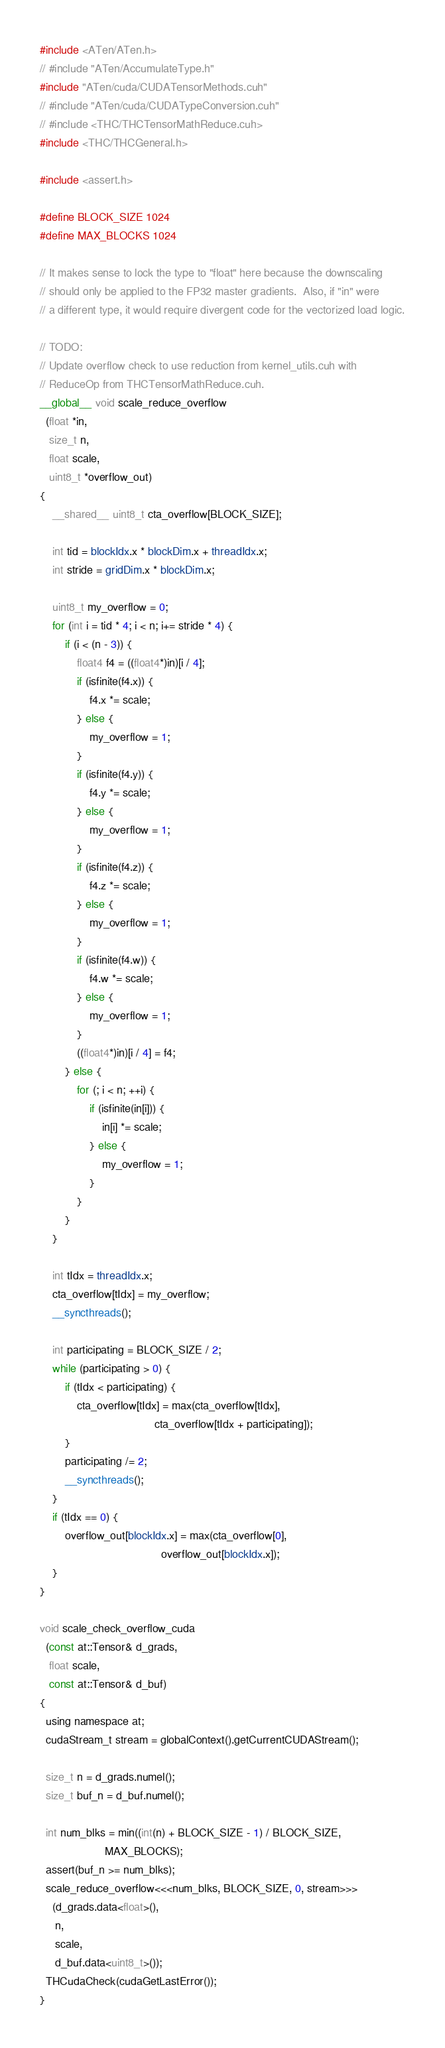Convert code to text. <code><loc_0><loc_0><loc_500><loc_500><_Cuda_>#include <ATen/ATen.h>
// #include "ATen/AccumulateType.h"
#include "ATen/cuda/CUDATensorMethods.cuh"
// #include "ATen/cuda/CUDATypeConversion.cuh"
// #include <THC/THCTensorMathReduce.cuh>
#include <THC/THCGeneral.h>

#include <assert.h>

#define BLOCK_SIZE 1024
#define MAX_BLOCKS 1024

// It makes sense to lock the type to "float" here because the downscaling
// should only be applied to the FP32 master gradients.  Also, if "in" were 
// a different type, it would require divergent code for the vectorized load logic.

// TODO:  
// Update overflow check to use reduction from kernel_utils.cuh with 
// ReduceOp from THCTensorMathReduce.cuh.
__global__ void scale_reduce_overflow
  (float *in, 
   size_t n, 
   float scale,
   uint8_t *overflow_out) 
{
    __shared__ uint8_t cta_overflow[BLOCK_SIZE];

    int tid = blockIdx.x * blockDim.x + threadIdx.x;
    int stride = gridDim.x * blockDim.x;

    uint8_t my_overflow = 0;
    for (int i = tid * 4; i < n; i+= stride * 4) {
        if (i < (n - 3)) {
            float4 f4 = ((float4*)in)[i / 4];
            if (isfinite(f4.x)) {
                f4.x *= scale;
            } else {
                my_overflow = 1;
            }
            if (isfinite(f4.y)) {
                f4.y *= scale;
            } else {
                my_overflow = 1;
            }
            if (isfinite(f4.z)) {
                f4.z *= scale;
            } else {
                my_overflow = 1;
            }
            if (isfinite(f4.w)) {
                f4.w *= scale;
            } else {
                my_overflow = 1;
            }
            ((float4*)in)[i / 4] = f4;
        } else {
            for (; i < n; ++i) {
                if (isfinite(in[i])) {
                    in[i] *= scale;
                } else {
                    my_overflow = 1;
                }
            }
        }
    }

    int tIdx = threadIdx.x;
    cta_overflow[tIdx] = my_overflow;
    __syncthreads();

    int participating = BLOCK_SIZE / 2;
    while (participating > 0) {
        if (tIdx < participating) {
            cta_overflow[tIdx] = max(cta_overflow[tIdx],
                                     cta_overflow[tIdx + participating]);
        }
        participating /= 2;
        __syncthreads();
    }
    if (tIdx == 0) {
        overflow_out[blockIdx.x] = max(cta_overflow[0],
                                       overflow_out[blockIdx.x]);
    }
}

void scale_check_overflow_cuda
  (const at::Tensor& d_grads, 
   float scale,
   const at::Tensor& d_buf) 
{
  using namespace at;
  cudaStream_t stream = globalContext().getCurrentCUDAStream();
  
  size_t n = d_grads.numel();
  size_t buf_n = d_buf.numel();

  int num_blks = min((int(n) + BLOCK_SIZE - 1) / BLOCK_SIZE,
                     MAX_BLOCKS);
  assert(buf_n >= num_blks);
  scale_reduce_overflow<<<num_blks, BLOCK_SIZE, 0, stream>>>
    (d_grads.data<float>(), 
     n, 
     scale, 
     d_buf.data<uint8_t>());
  THCudaCheck(cudaGetLastError());
}

</code> 